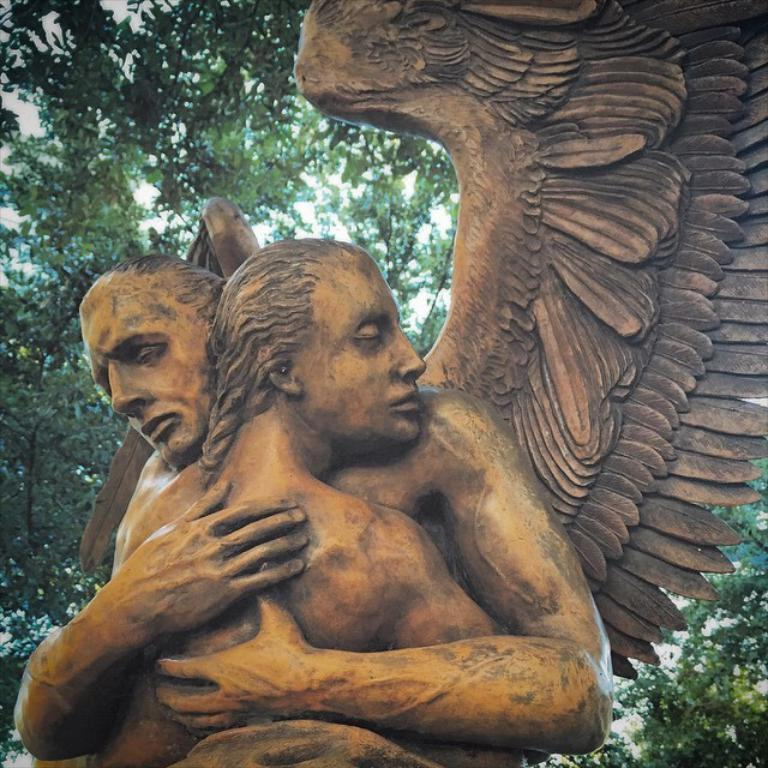What is the main subject of the image? There is a sculpture in the image. Can you describe the setting of the image? There are trees visible in the background of the image. How many clams are sitting on the crate in the image? There are no clams or crates present in the image; it features a sculpture and trees in the background. 